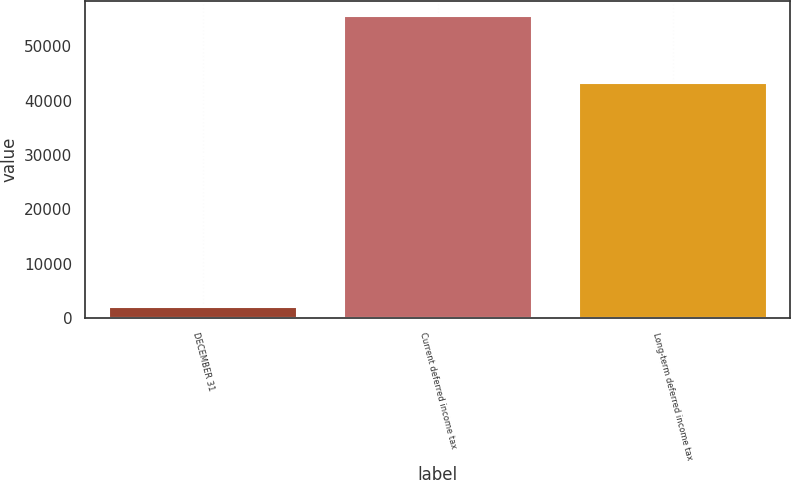Convert chart. <chart><loc_0><loc_0><loc_500><loc_500><bar_chart><fcel>DECEMBER 31<fcel>Current deferred income tax<fcel>Long-term deferred income tax<nl><fcel>2007<fcel>55522<fcel>43206<nl></chart> 